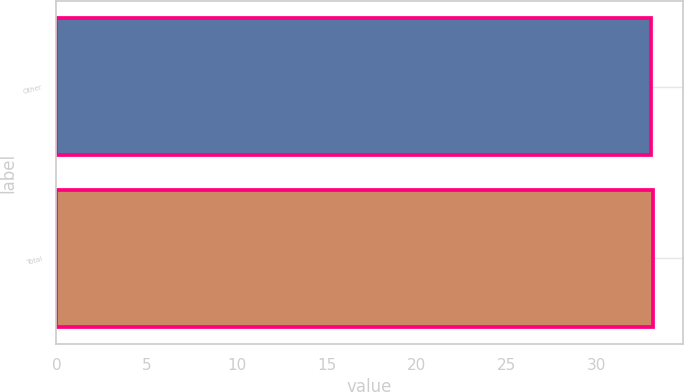<chart> <loc_0><loc_0><loc_500><loc_500><bar_chart><fcel>Other<fcel>Total<nl><fcel>33<fcel>33.1<nl></chart> 